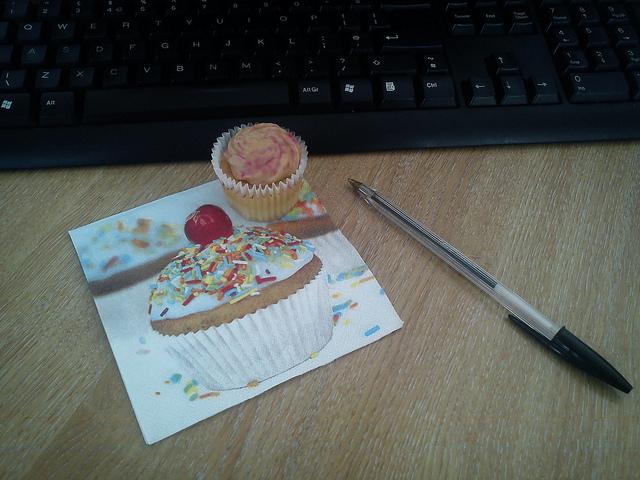Is there a black pen in no the desk?
Be succinct. Yes. How many real cupcakes are in the photo?
Quick response, please. 1. Where are the cherries?
Concise answer only. On cupcake. What is on top of the cupcake in the picture?
Be succinct. Cherry. 